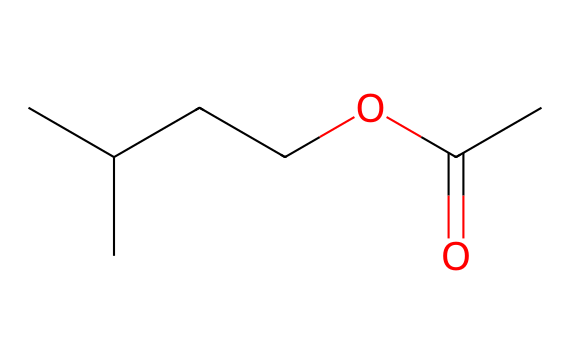What is the chemical name of this ester? The SMILES representation indicates an ester formed from isoamyl alcohol and acetic acid, which is known as isoamyl acetate.
Answer: isoamyl acetate How many carbon atoms are present in the structure? By analyzing the SMILES, we can count the carbon atoms: there are 5 carbons in the branched chain (CC(C)CC) and 2 in the acetate group (C(C)=O), totaling 7 carbon atoms.
Answer: 7 What functional group is present in this compound? The structure possesses a carbonyl group (C=O) attached to an alkoxy group (OC), characteristic of esters. Thus, the functional group is an ester.
Answer: ester How many oxygen atoms are present in isoamyl acetate? In the SMILES, we can see there is one oxygen in the alkoxy part and one in the carbonyl part, resulting in a total of 2 oxygen atoms.
Answer: 2 What type of smell is associated with isoamyl acetate? Isoamyl acetate is commonly known for its distinct fruity smell, specifically resembling bananas, which is often used in food flavorings.
Answer: banana Which part of the molecule is responsible for its fruity aroma? The ester functional group and the specific carbon chain structure contribute to the compound's fruity aroma. In this case, the isoamyl part, being a branched chain, enhances the banana scent.
Answer: isoamyl part 